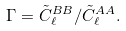Convert formula to latex. <formula><loc_0><loc_0><loc_500><loc_500>\Gamma = \tilde { C } _ { \ell } ^ { B B } / \tilde { C } _ { \ell } ^ { A A } .</formula> 